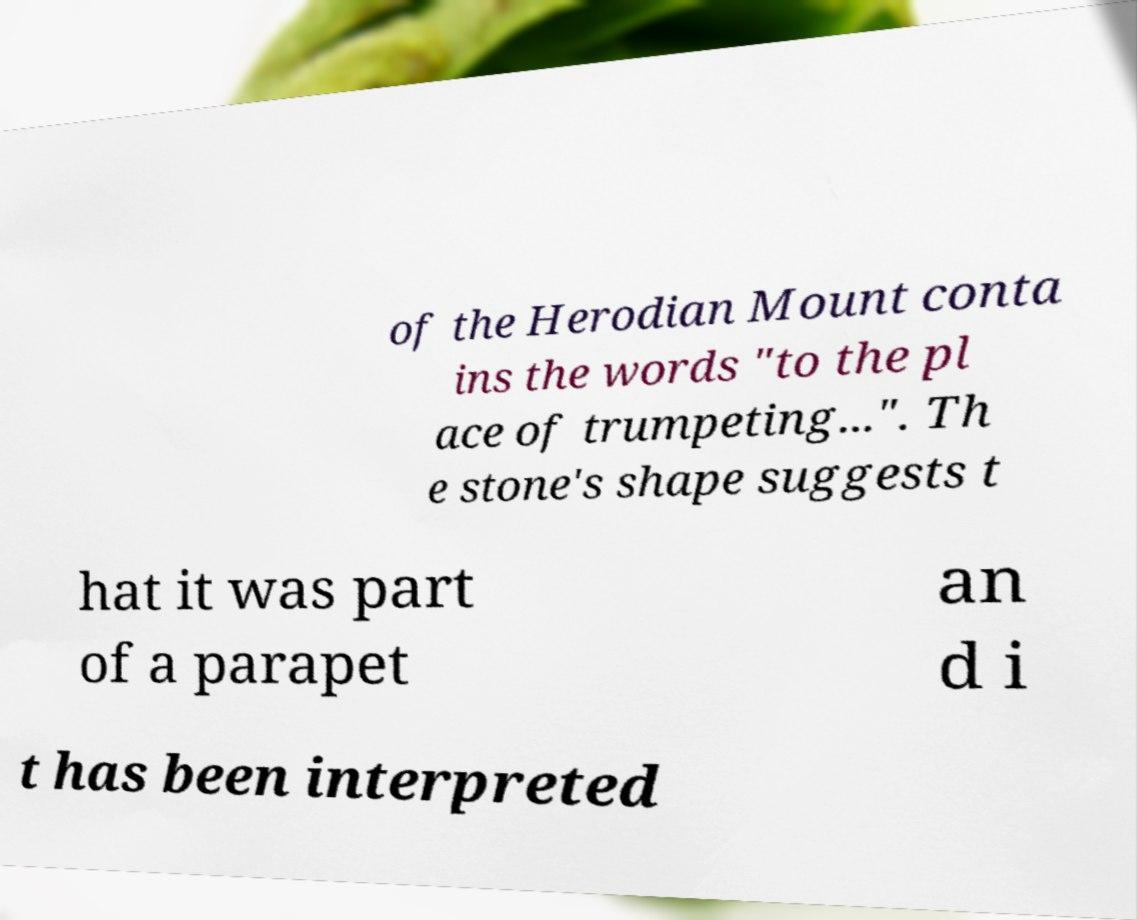Could you extract and type out the text from this image? of the Herodian Mount conta ins the words "to the pl ace of trumpeting...". Th e stone's shape suggests t hat it was part of a parapet an d i t has been interpreted 